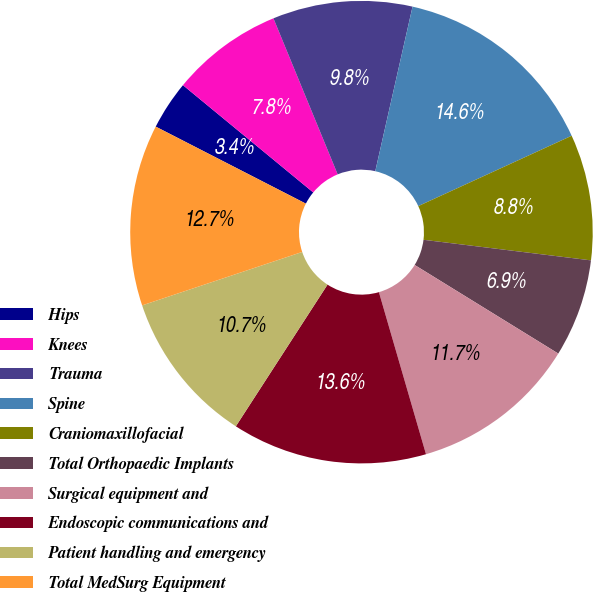<chart> <loc_0><loc_0><loc_500><loc_500><pie_chart><fcel>Hips<fcel>Knees<fcel>Trauma<fcel>Spine<fcel>Craniomaxillofacial<fcel>Total Orthopaedic Implants<fcel>Surgical equipment and<fcel>Endoscopic communications and<fcel>Patient handling and emergency<fcel>Total MedSurg Equipment<nl><fcel>3.42%<fcel>7.82%<fcel>9.76%<fcel>14.61%<fcel>8.79%<fcel>6.85%<fcel>11.7%<fcel>13.64%<fcel>10.73%<fcel>12.67%<nl></chart> 